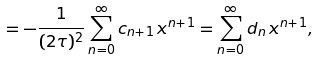<formula> <loc_0><loc_0><loc_500><loc_500>= - \frac { 1 } { ( 2 \tau ) ^ { 2 } } \sum _ { n = 0 } ^ { \infty } c _ { n + 1 } \, x ^ { n + 1 } = \sum _ { n = 0 } ^ { \infty } d _ { n } \, x ^ { n + 1 } ,</formula> 